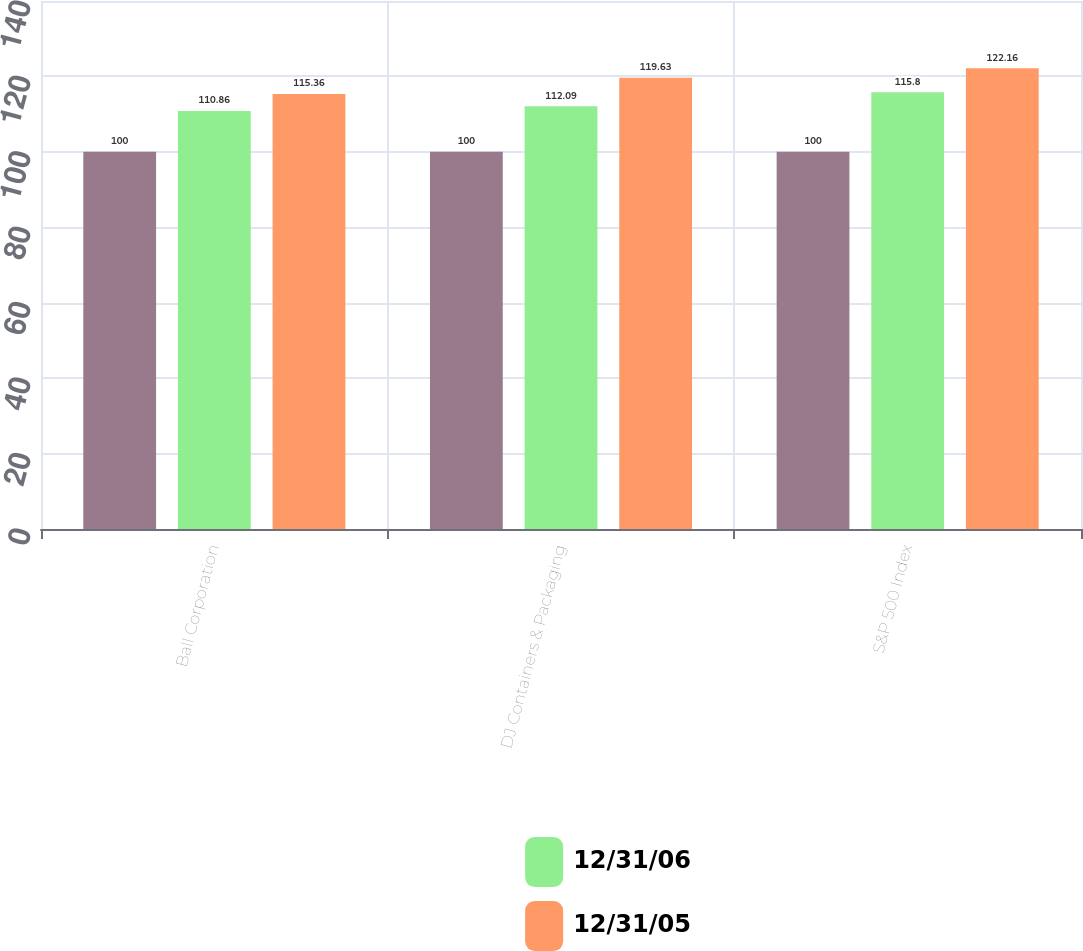Convert chart to OTSL. <chart><loc_0><loc_0><loc_500><loc_500><stacked_bar_chart><ecel><fcel>Ball Corporation<fcel>DJ Containers & Packaging<fcel>S&P 500 Index<nl><fcel>nan<fcel>100<fcel>100<fcel>100<nl><fcel>12/31/06<fcel>110.86<fcel>112.09<fcel>115.8<nl><fcel>12/31/05<fcel>115.36<fcel>119.63<fcel>122.16<nl></chart> 